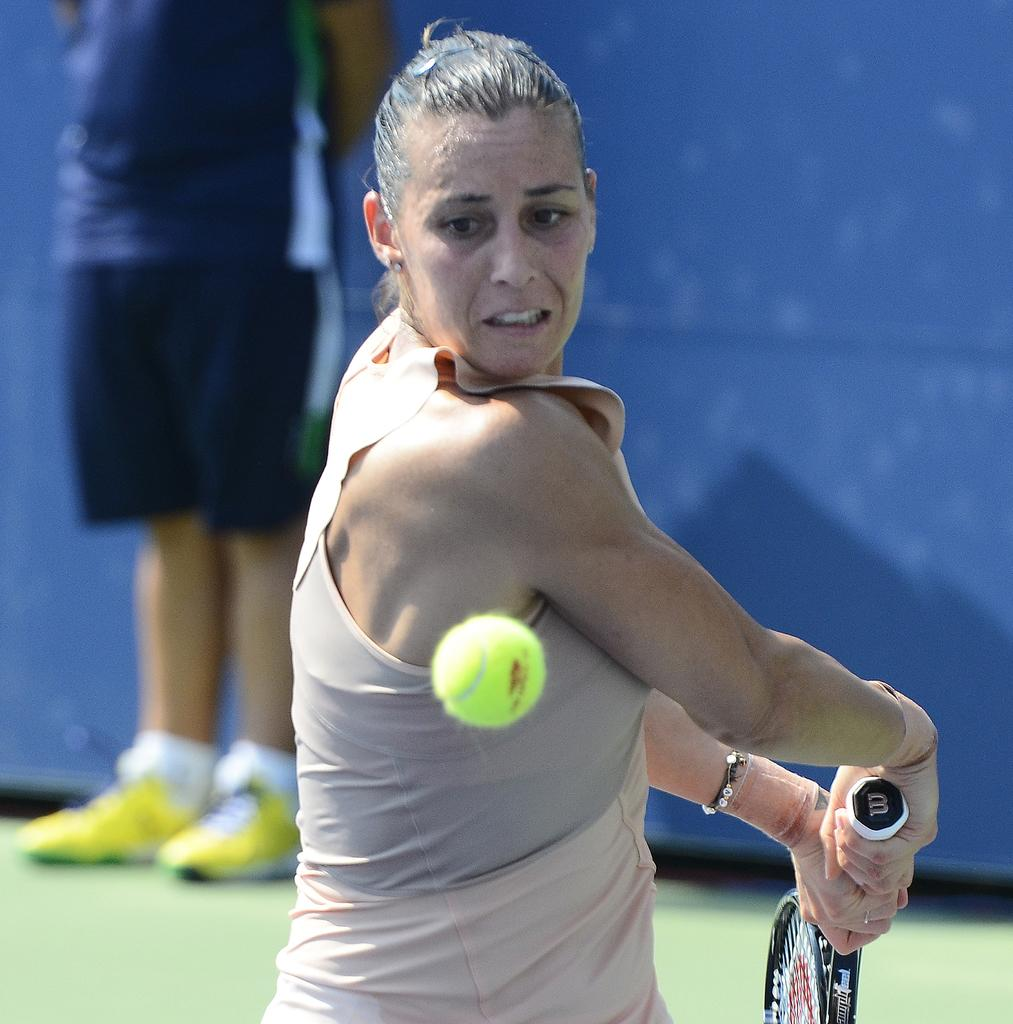What is the main subject of the image? The main subject of the image is a woman. Can you describe what the woman is wearing? The woman is wearing a sleeveless top. What is the woman holding in the image? The woman is holding a tennis racket. What action is the woman about to perform? The woman is about to hit a ball. Can you describe the person standing behind the woman? The person is standing behind the woman, but no specific details about their appearance or clothing are provided. What is the background of the scene? The scene is on a grass floor, and there is a wall behind the person standing behind the woman. What type of secretary is standing next to the woman in the image? There is no mention of a secretary in the image, and the person standing behind the woman is not described as such. 